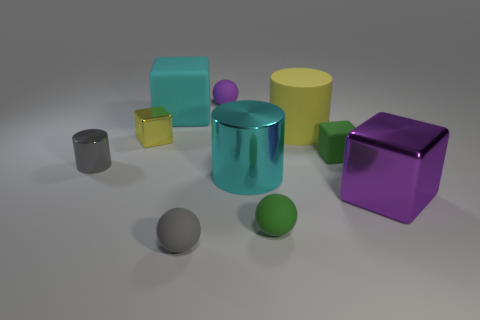Subtract all shiny cylinders. How many cylinders are left? 1 Subtract all cyan blocks. How many blocks are left? 3 Subtract 2 cylinders. How many cylinders are left? 1 Subtract all cylinders. How many objects are left? 7 Subtract all yellow cubes. Subtract all brown spheres. How many cubes are left? 3 Subtract all blue cylinders. How many red spheres are left? 0 Subtract 1 purple blocks. How many objects are left? 9 Subtract all tiny gray balls. Subtract all green matte objects. How many objects are left? 7 Add 5 metal objects. How many metal objects are left? 9 Add 7 tiny purple matte cylinders. How many tiny purple matte cylinders exist? 7 